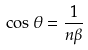<formula> <loc_0><loc_0><loc_500><loc_500>\cos \theta = \frac { 1 } { n \beta }</formula> 